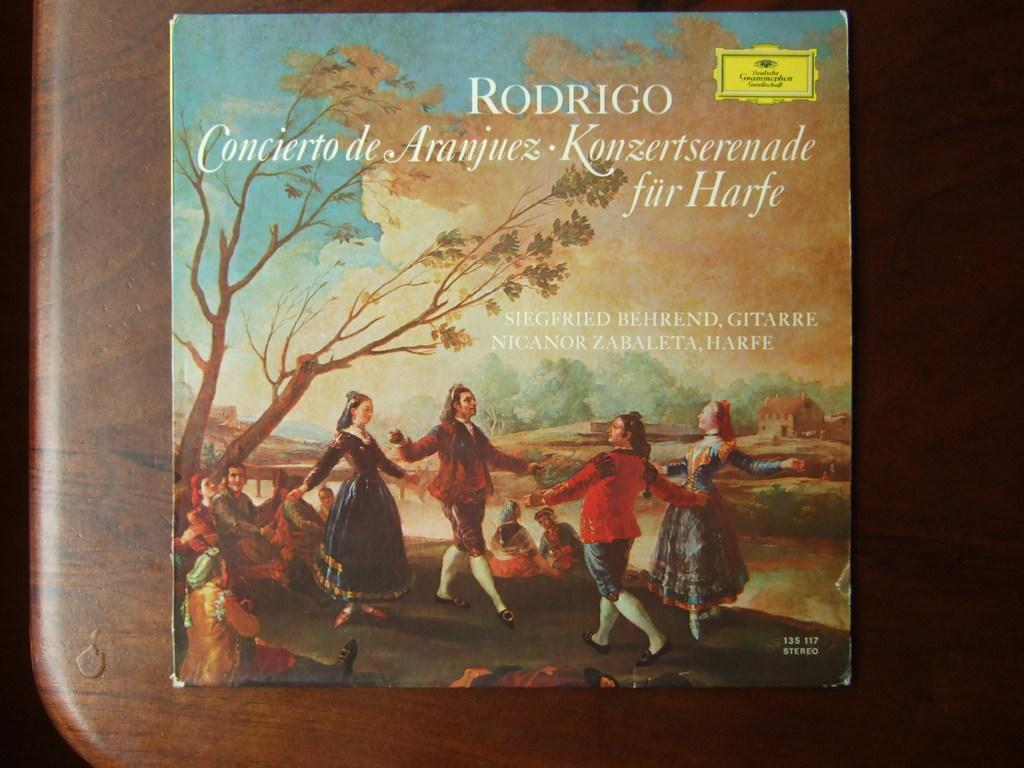Provide a one-sentence caption for the provided image. A Rodrigo album featuring old art is on a wooden table. 